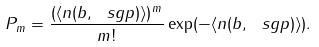<formula> <loc_0><loc_0><loc_500><loc_500>P _ { m } = \frac { ( \langle n ( b , \ s g p ) \rangle ) ^ { m } } { m ! } \exp ( - \langle n ( b , \ s g p ) \rangle ) .</formula> 